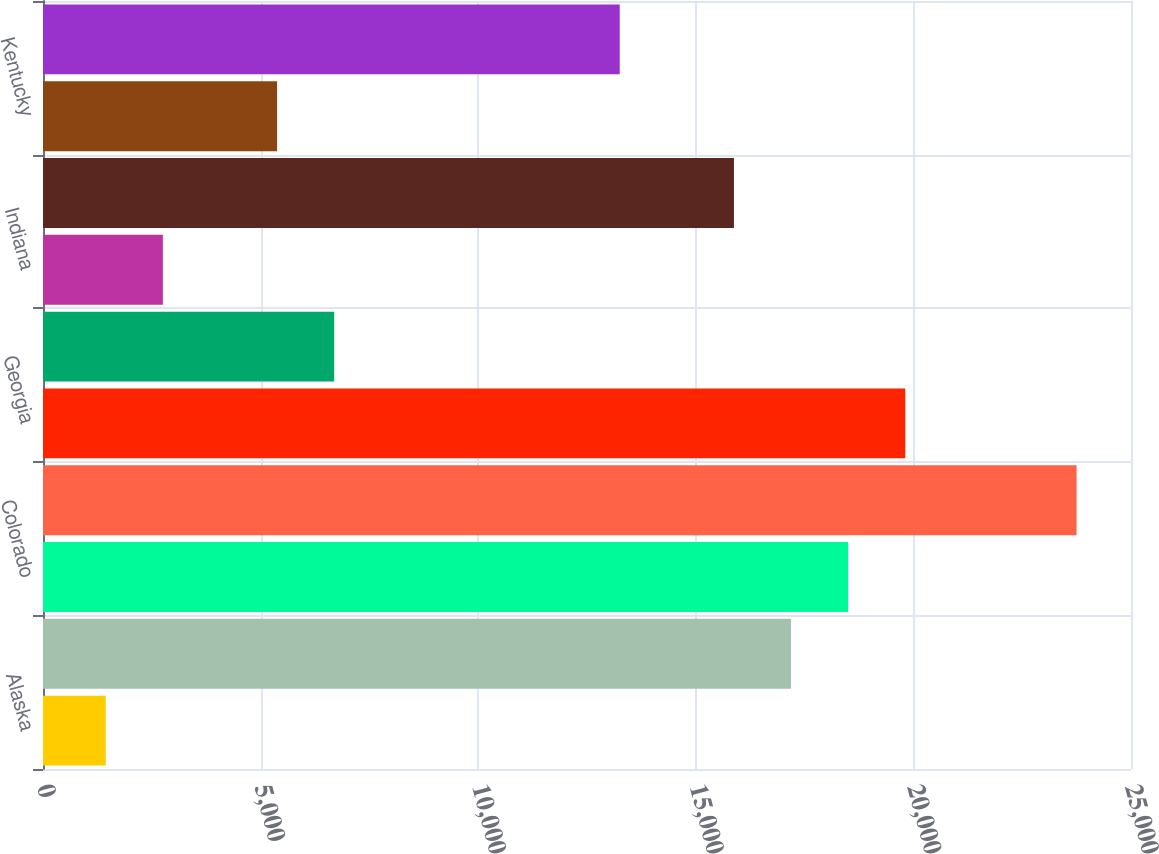Convert chart to OTSL. <chart><loc_0><loc_0><loc_500><loc_500><bar_chart><fcel>Alaska<fcel>California<fcel>Colorado<fcel>Florida<fcel>Georgia<fcel>Idaho<fcel>Indiana<fcel>Kansas<fcel>Kentucky<fcel>Louisiana<nl><fcel>1442.2<fcel>17188.6<fcel>18500.8<fcel>23749.6<fcel>19813<fcel>6691<fcel>2754.4<fcel>15876.4<fcel>5378.8<fcel>13252<nl></chart> 